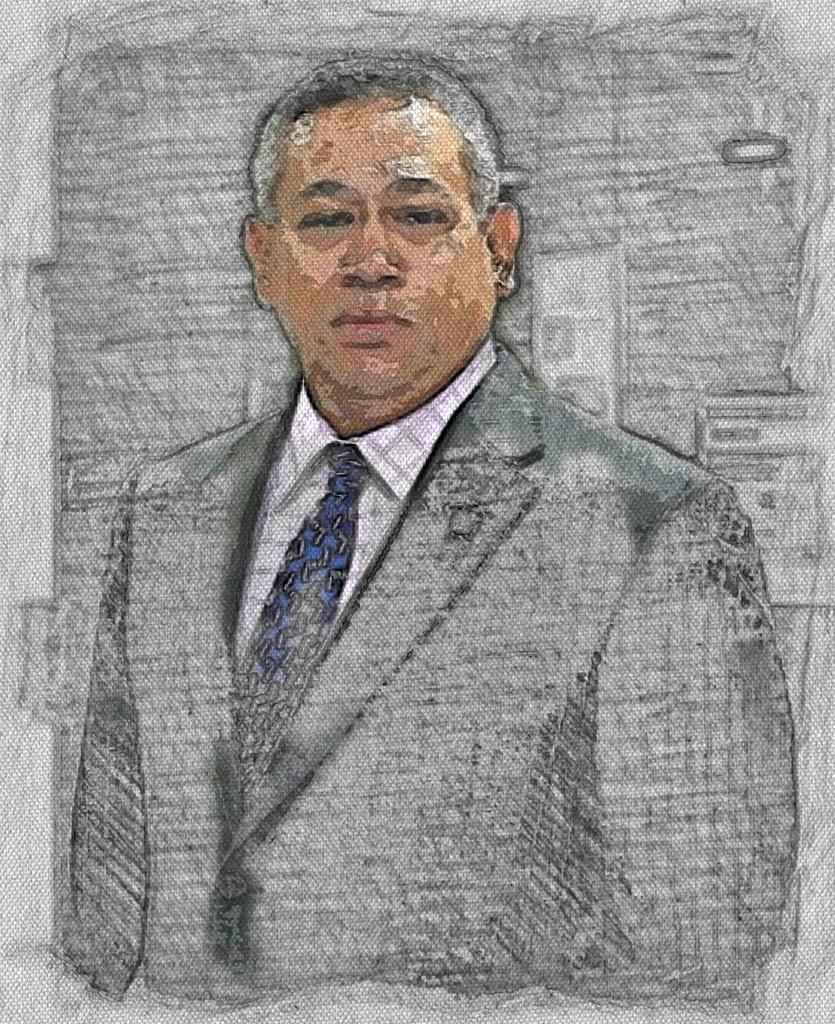Can you describe this image briefly? It looks like an edited image of a person and the person is in the blazer. 